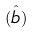Convert formula to latex. <formula><loc_0><loc_0><loc_500><loc_500>( \hat { b } )</formula> 